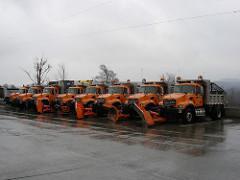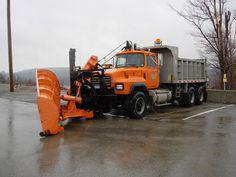The first image is the image on the left, the second image is the image on the right. Given the left and right images, does the statement "There is one white vehicle." hold true? Answer yes or no. No. The first image is the image on the left, the second image is the image on the right. Evaluate the accuracy of this statement regarding the images: "Left image shows one orange truck in front of a yellower piece of equipment.". Is it true? Answer yes or no. No. 